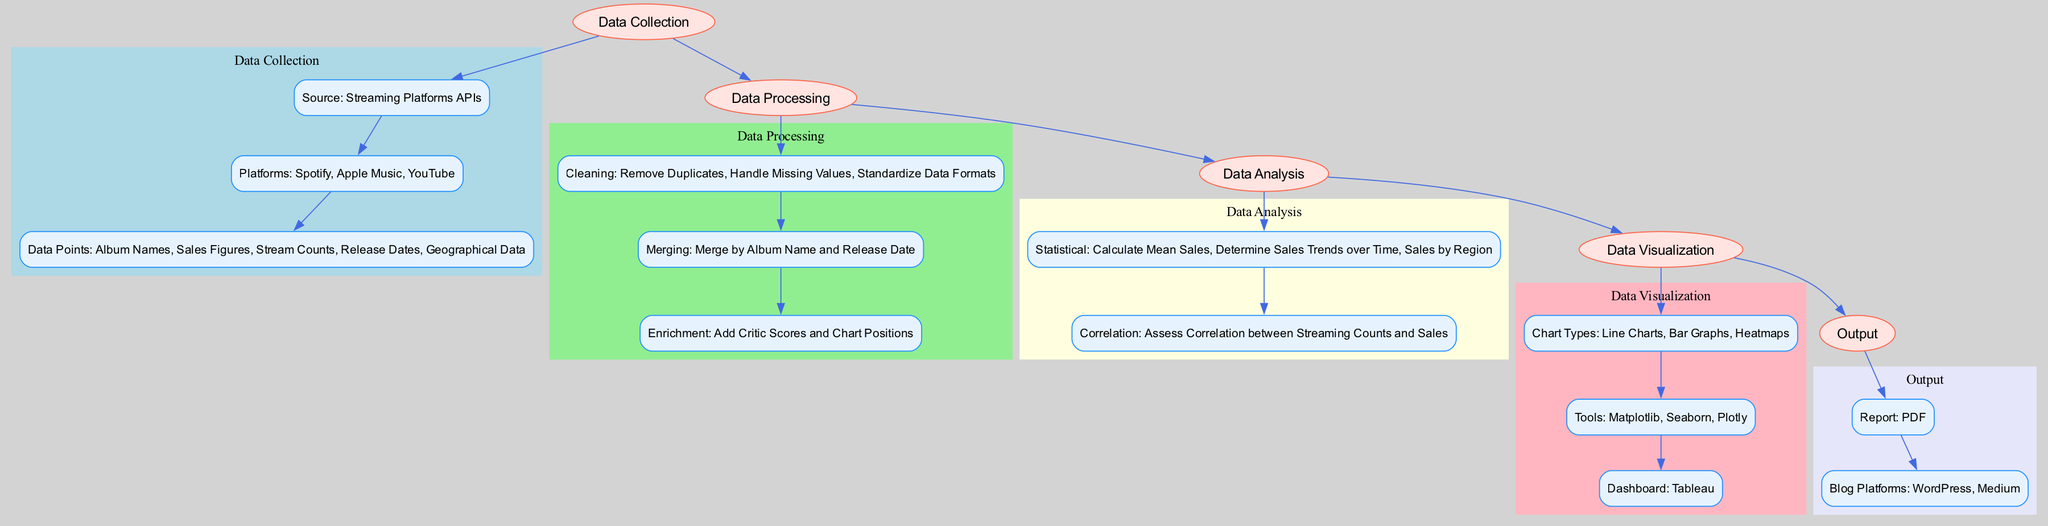What is the main source of data collection? According to the diagram, the main source for data collection is "Streaming Platforms APIs," which is specifically mentioned in the Data Collection section.
Answer: Streaming Platforms APIs How many platforms are listed under data collection? The diagram lists three platforms: Spotify, Apple Music, and YouTube in the Data Collection section. Hence, the total count is three.
Answer: 3 What is the procedure for data merging? The diagram specifies the merging procedure for the Data Processing section, stating "Merge by Album Name and Release Date" as the method used.
Answer: Merge by Album Name and Release Date Which tool is used for data cleaning? The Data Processing segment of the diagram explicitly lists "Python" as one of the tools used for data cleaning.
Answer: Python What types of charts are included for data visualization? In the Data Visualization section of the diagram, three types of charts are listed: Line Charts, Bar Graphs, and Heatmaps, summarizing the visualization methods available.
Answer: Line Charts, Bar Graphs, Heatmaps What is the final format of the report generation? The Output portion of the diagram indicates that the report generation format is "PDF," which answers the query regarding output formatting.
Answer: PDF In the data analysis section, what is analyzed for correlation? The diagram mentions analyzing "Correlation between Streaming Counts and Sales" as the main task in the correlation analysis of the Data Analysis section, providing clarity on the focus of the analysis.
Answer: Correlation between Streaming Counts and Sales How many main processes are there in the diagram? Upon reviewing the diagram, five main processes are identified: Data Collection, Data Processing, Data Analysis, Data Visualization, and Output, making the count straightforward.
Answer: 5 What is the software used for the dashboards? The Data Visualization section clearly states that "Tableau" is the software utilized for creating dashboards, corresponding to the visual representation provided in the diagram.
Answer: Tableau 